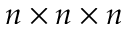<formula> <loc_0><loc_0><loc_500><loc_500>n \times n \times n</formula> 